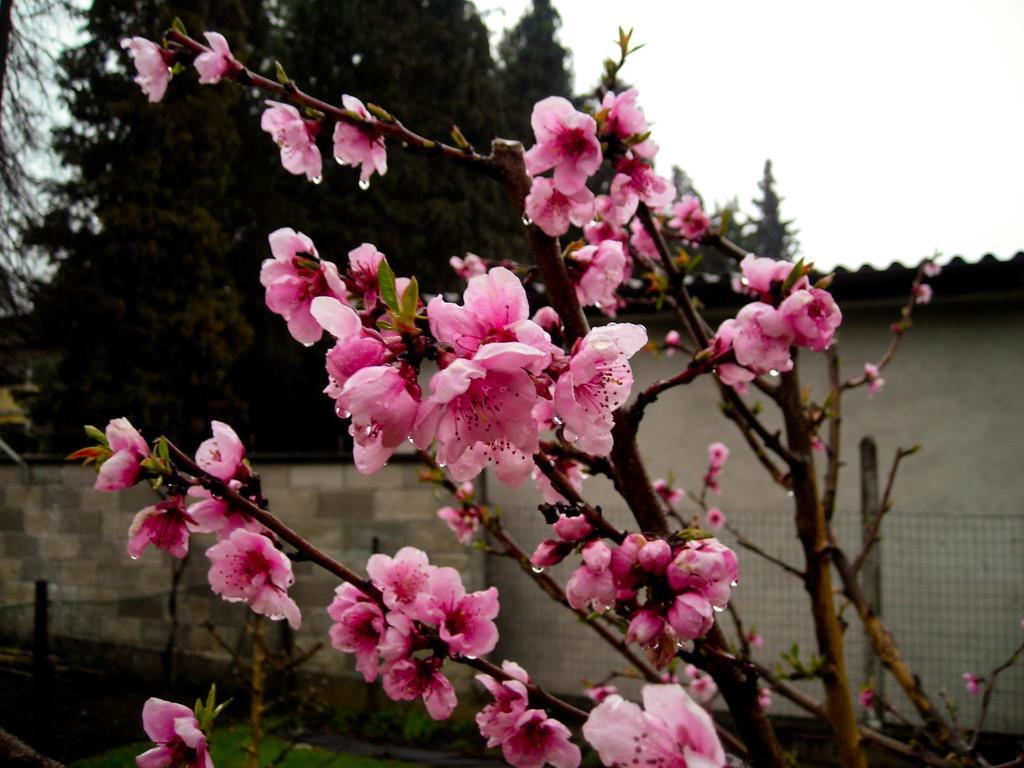Describe this image in one or two sentences. In this image there are trees and we can see flowers which are in pink color. There is a wall and we can see a shed. In the background there is sky. 